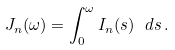Convert formula to latex. <formula><loc_0><loc_0><loc_500><loc_500>J _ { n } ( \omega ) = \int _ { 0 } ^ { \omega } I _ { n } ( s ) \ d s \, .</formula> 